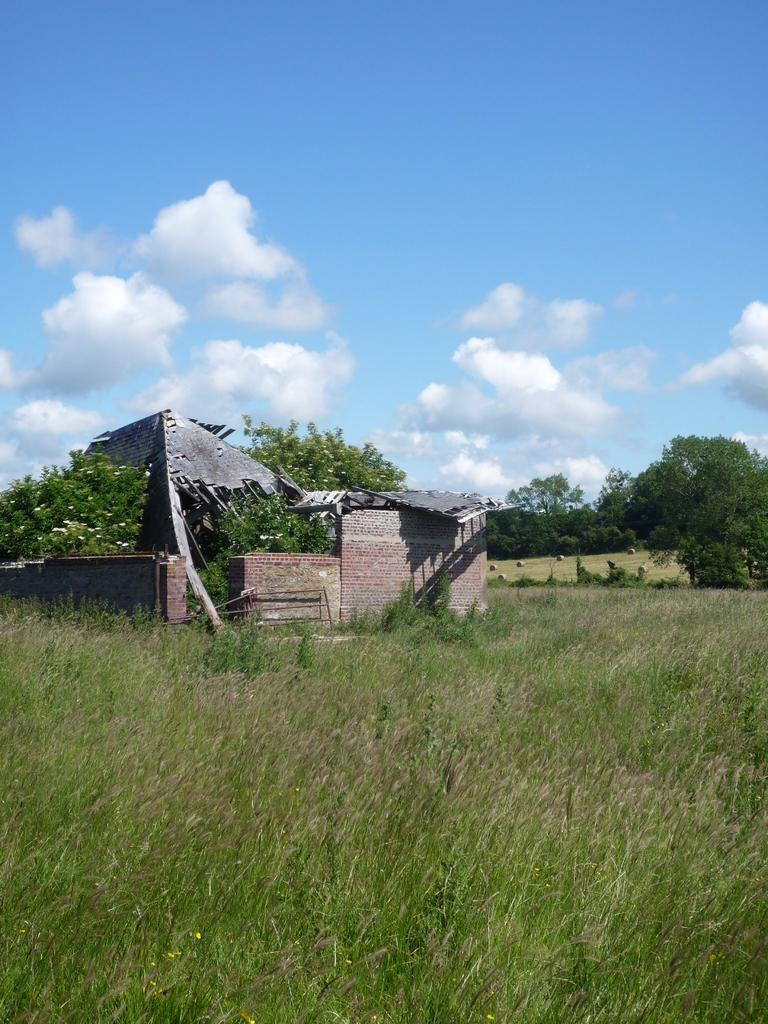Describe this image in one or two sentences. In this image in the center there is one house, at the bottom there are some plants and in the background there are some trees and wall. 